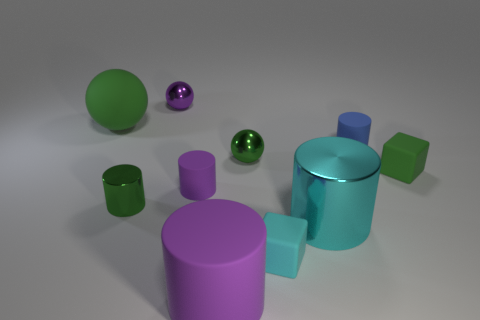How many other objects are the same material as the big cyan object?
Keep it short and to the point. 3. Do the green cylinder and the tiny cube that is right of the big cyan object have the same material?
Keep it short and to the point. No. How many objects are green metal balls that are left of the tiny blue cylinder or things that are to the left of the blue rubber thing?
Provide a succinct answer. 8. How many other objects are the same color as the small metal cylinder?
Your answer should be compact. 3. Are there more tiny purple rubber cylinders to the left of the small green shiny cylinder than cyan metallic objects in front of the large cyan metallic thing?
Provide a succinct answer. No. Are there any other things that have the same size as the green rubber cube?
Make the answer very short. Yes. What number of balls are tiny cyan rubber objects or large metallic objects?
Make the answer very short. 0. How many objects are either small cylinders behind the tiny purple cylinder or large blue rubber cylinders?
Keep it short and to the point. 1. What shape is the large matte thing that is to the right of the small object that is behind the cylinder that is right of the big cyan metal cylinder?
Offer a very short reply. Cylinder. How many other small shiny objects have the same shape as the purple metal object?
Ensure brevity in your answer.  1. 